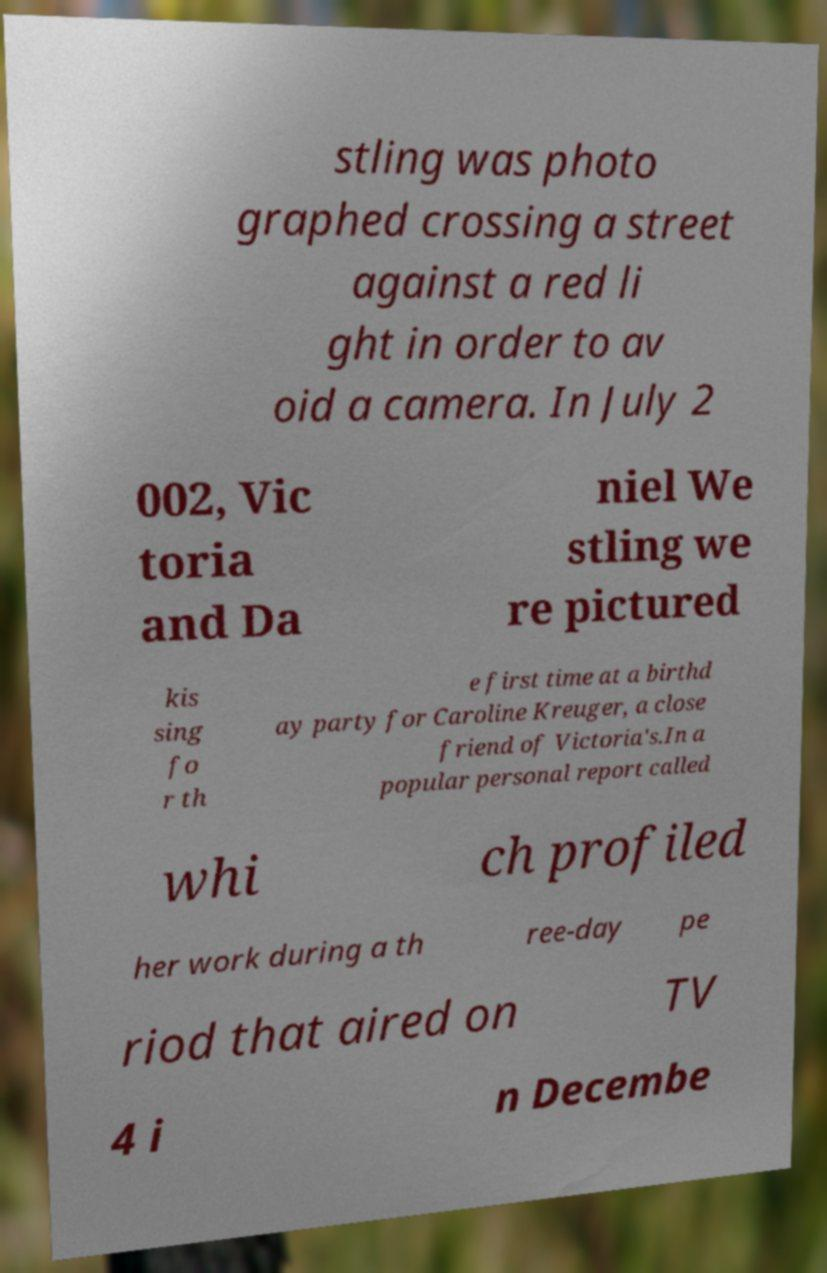There's text embedded in this image that I need extracted. Can you transcribe it verbatim? stling was photo graphed crossing a street against a red li ght in order to av oid a camera. In July 2 002, Vic toria and Da niel We stling we re pictured kis sing fo r th e first time at a birthd ay party for Caroline Kreuger, a close friend of Victoria's.In a popular personal report called whi ch profiled her work during a th ree-day pe riod that aired on TV 4 i n Decembe 